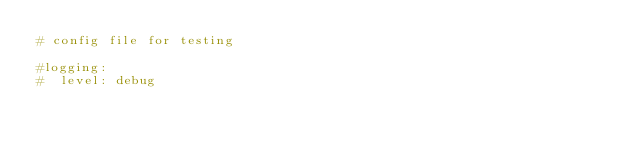Convert code to text. <code><loc_0><loc_0><loc_500><loc_500><_YAML_># config file for testing

#logging:
#  level: debug</code> 